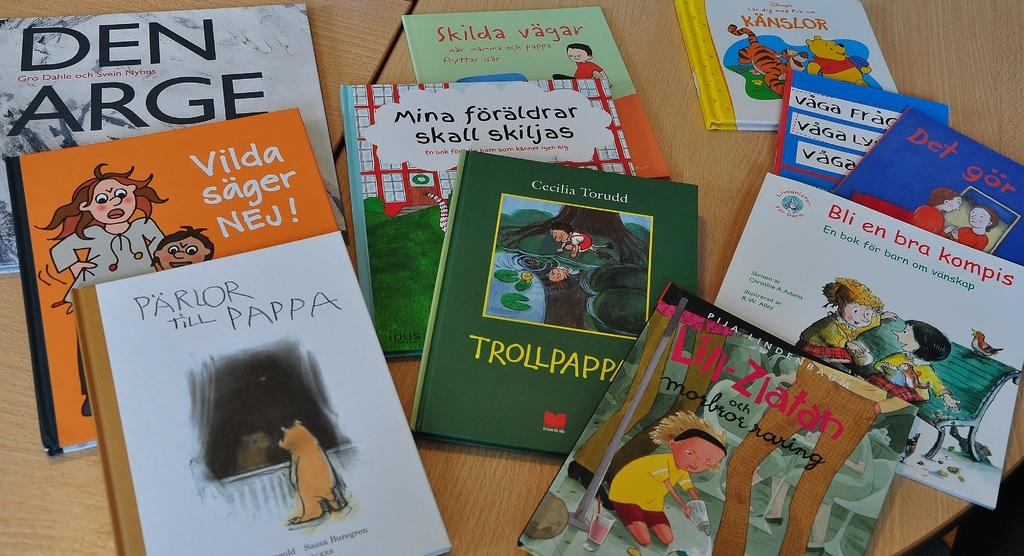What is the main subject of the image? The main subject of the image is many books. What can be seen on the books? The books have text and pictures on them. Where are the books located? The books are on a table. What material is the table made of? The table is made of wood. Can you see any ants crawling on the books in the image? There are no ants visible in the image. What color is the vein running through the book on the left side of the image? There are no veins present in the image, as books do not have veins. 